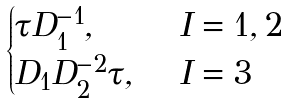Convert formula to latex. <formula><loc_0><loc_0><loc_500><loc_500>\begin{cases} \tau D _ { 1 } ^ { - 1 } , & \ I = 1 , 2 \\ D _ { 1 } D _ { 2 } ^ { - 2 } \tau , & \ I = 3 \\ \end{cases}</formula> 